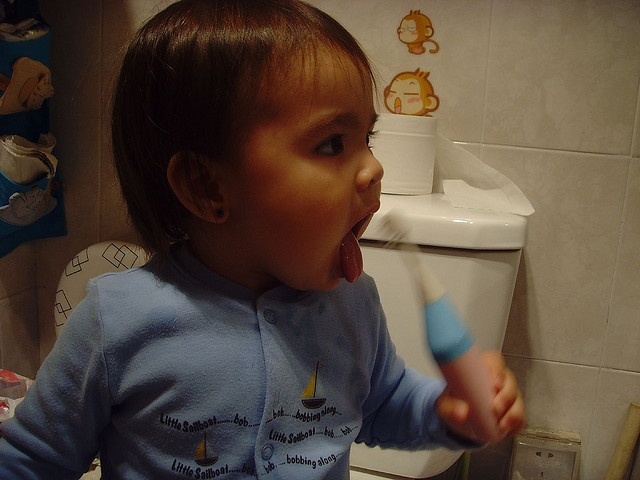Read and extract the text from this image. bob little Sailboat little bobbing 